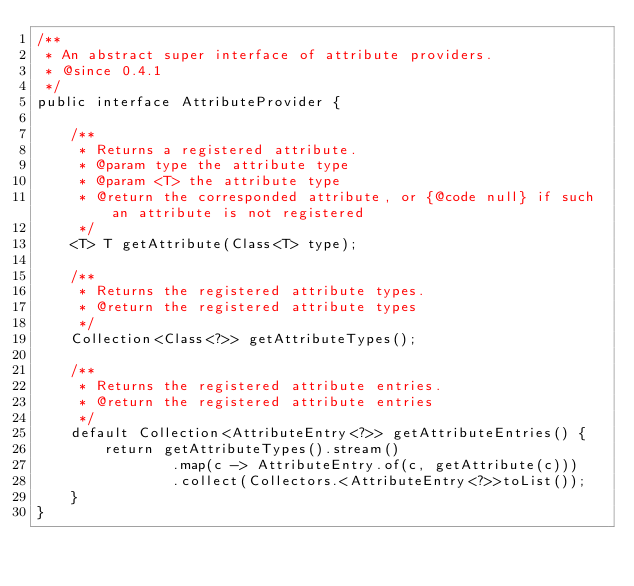<code> <loc_0><loc_0><loc_500><loc_500><_Java_>/**
 * An abstract super interface of attribute providers.
 * @since 0.4.1
 */
public interface AttributeProvider {

    /**
     * Returns a registered attribute.
     * @param type the attribute type
     * @param <T> the attribute type
     * @return the corresponded attribute, or {@code null} if such an attribute is not registered
     */
    <T> T getAttribute(Class<T> type);

    /**
     * Returns the registered attribute types.
     * @return the registered attribute types
     */
    Collection<Class<?>> getAttributeTypes();

    /**
     * Returns the registered attribute entries.
     * @return the registered attribute entries
     */
    default Collection<AttributeEntry<?>> getAttributeEntries() {
        return getAttributeTypes().stream()
                .map(c -> AttributeEntry.of(c, getAttribute(c)))
                .collect(Collectors.<AttributeEntry<?>>toList());
    }
}
</code> 